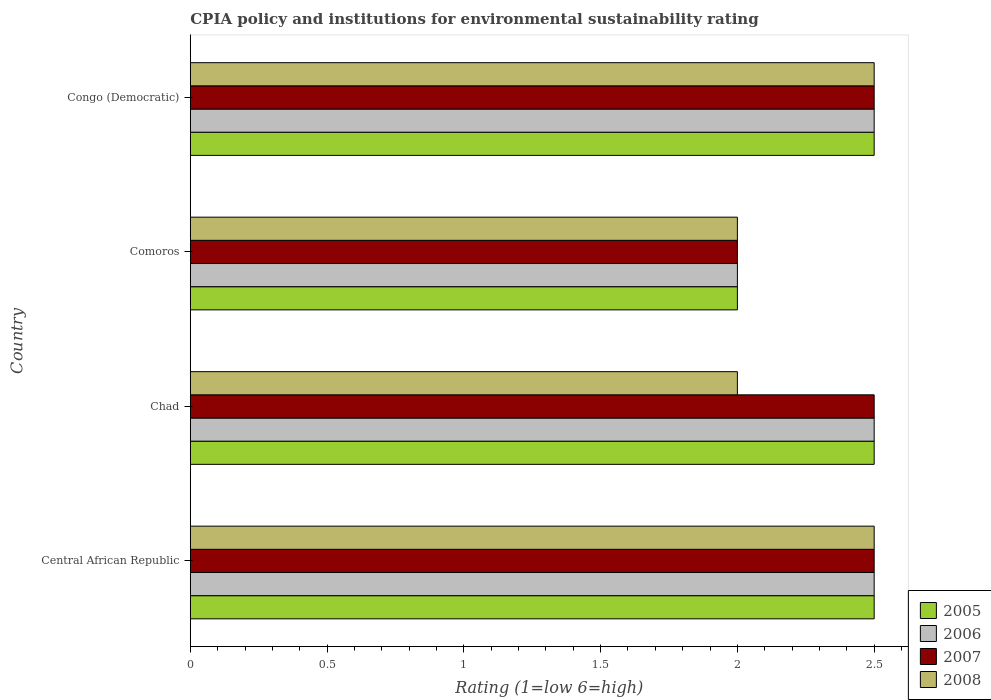How many groups of bars are there?
Make the answer very short. 4. Are the number of bars per tick equal to the number of legend labels?
Make the answer very short. Yes. Are the number of bars on each tick of the Y-axis equal?
Keep it short and to the point. Yes. How many bars are there on the 3rd tick from the top?
Offer a very short reply. 4. How many bars are there on the 1st tick from the bottom?
Your response must be concise. 4. What is the label of the 1st group of bars from the top?
Provide a short and direct response. Congo (Democratic). What is the CPIA rating in 2005 in Comoros?
Offer a terse response. 2. Across all countries, what is the minimum CPIA rating in 2007?
Your response must be concise. 2. In which country was the CPIA rating in 2007 maximum?
Your answer should be compact. Central African Republic. In which country was the CPIA rating in 2007 minimum?
Give a very brief answer. Comoros. What is the total CPIA rating in 2008 in the graph?
Offer a terse response. 9. What is the difference between the CPIA rating in 2007 in Congo (Democratic) and the CPIA rating in 2005 in Central African Republic?
Provide a succinct answer. 0. What is the average CPIA rating in 2007 per country?
Give a very brief answer. 2.38. What is the difference between the CPIA rating in 2007 and CPIA rating in 2006 in Congo (Democratic)?
Provide a succinct answer. 0. Is the difference between the CPIA rating in 2007 in Comoros and Congo (Democratic) greater than the difference between the CPIA rating in 2006 in Comoros and Congo (Democratic)?
Make the answer very short. No. What is the difference between the highest and the lowest CPIA rating in 2008?
Keep it short and to the point. 0.5. In how many countries, is the CPIA rating in 2007 greater than the average CPIA rating in 2007 taken over all countries?
Offer a very short reply. 3. How many countries are there in the graph?
Give a very brief answer. 4. What is the difference between two consecutive major ticks on the X-axis?
Give a very brief answer. 0.5. Are the values on the major ticks of X-axis written in scientific E-notation?
Offer a terse response. No. Does the graph contain grids?
Give a very brief answer. No. Where does the legend appear in the graph?
Your answer should be compact. Bottom right. What is the title of the graph?
Make the answer very short. CPIA policy and institutions for environmental sustainability rating. Does "1974" appear as one of the legend labels in the graph?
Keep it short and to the point. No. What is the Rating (1=low 6=high) in 2005 in Central African Republic?
Keep it short and to the point. 2.5. What is the Rating (1=low 6=high) of 2008 in Central African Republic?
Offer a terse response. 2.5. What is the Rating (1=low 6=high) in 2005 in Chad?
Your answer should be compact. 2.5. What is the Rating (1=low 6=high) of 2006 in Chad?
Offer a terse response. 2.5. What is the Rating (1=low 6=high) in 2007 in Comoros?
Make the answer very short. 2. What is the Rating (1=low 6=high) of 2008 in Comoros?
Ensure brevity in your answer.  2. What is the Rating (1=low 6=high) of 2006 in Congo (Democratic)?
Your answer should be compact. 2.5. Across all countries, what is the maximum Rating (1=low 6=high) of 2005?
Keep it short and to the point. 2.5. Across all countries, what is the maximum Rating (1=low 6=high) of 2007?
Offer a very short reply. 2.5. Across all countries, what is the maximum Rating (1=low 6=high) of 2008?
Your response must be concise. 2.5. Across all countries, what is the minimum Rating (1=low 6=high) of 2005?
Keep it short and to the point. 2. Across all countries, what is the minimum Rating (1=low 6=high) of 2006?
Your answer should be very brief. 2. Across all countries, what is the minimum Rating (1=low 6=high) of 2008?
Keep it short and to the point. 2. What is the total Rating (1=low 6=high) in 2005 in the graph?
Make the answer very short. 9.5. What is the total Rating (1=low 6=high) of 2008 in the graph?
Provide a short and direct response. 9. What is the difference between the Rating (1=low 6=high) of 2006 in Central African Republic and that in Chad?
Your answer should be very brief. 0. What is the difference between the Rating (1=low 6=high) in 2007 in Central African Republic and that in Chad?
Make the answer very short. 0. What is the difference between the Rating (1=low 6=high) in 2006 in Central African Republic and that in Congo (Democratic)?
Ensure brevity in your answer.  0. What is the difference between the Rating (1=low 6=high) in 2007 in Central African Republic and that in Congo (Democratic)?
Offer a very short reply. 0. What is the difference between the Rating (1=low 6=high) of 2008 in Central African Republic and that in Congo (Democratic)?
Provide a short and direct response. 0. What is the difference between the Rating (1=low 6=high) of 2006 in Chad and that in Comoros?
Your answer should be very brief. 0.5. What is the difference between the Rating (1=low 6=high) in 2008 in Chad and that in Comoros?
Give a very brief answer. 0. What is the difference between the Rating (1=low 6=high) of 2006 in Chad and that in Congo (Democratic)?
Keep it short and to the point. 0. What is the difference between the Rating (1=low 6=high) in 2007 in Chad and that in Congo (Democratic)?
Offer a very short reply. 0. What is the difference between the Rating (1=low 6=high) in 2008 in Chad and that in Congo (Democratic)?
Offer a very short reply. -0.5. What is the difference between the Rating (1=low 6=high) of 2006 in Comoros and that in Congo (Democratic)?
Make the answer very short. -0.5. What is the difference between the Rating (1=low 6=high) in 2008 in Comoros and that in Congo (Democratic)?
Your answer should be compact. -0.5. What is the difference between the Rating (1=low 6=high) in 2005 in Central African Republic and the Rating (1=low 6=high) in 2007 in Chad?
Give a very brief answer. 0. What is the difference between the Rating (1=low 6=high) of 2005 in Central African Republic and the Rating (1=low 6=high) of 2008 in Chad?
Give a very brief answer. 0.5. What is the difference between the Rating (1=low 6=high) in 2006 in Central African Republic and the Rating (1=low 6=high) in 2008 in Chad?
Ensure brevity in your answer.  0.5. What is the difference between the Rating (1=low 6=high) of 2007 in Central African Republic and the Rating (1=low 6=high) of 2008 in Chad?
Your answer should be very brief. 0.5. What is the difference between the Rating (1=low 6=high) of 2005 in Central African Republic and the Rating (1=low 6=high) of 2007 in Comoros?
Ensure brevity in your answer.  0.5. What is the difference between the Rating (1=low 6=high) in 2005 in Central African Republic and the Rating (1=low 6=high) in 2008 in Comoros?
Offer a terse response. 0.5. What is the difference between the Rating (1=low 6=high) of 2006 in Central African Republic and the Rating (1=low 6=high) of 2008 in Comoros?
Make the answer very short. 0.5. What is the difference between the Rating (1=low 6=high) of 2005 in Central African Republic and the Rating (1=low 6=high) of 2007 in Congo (Democratic)?
Your answer should be very brief. 0. What is the difference between the Rating (1=low 6=high) of 2005 in Central African Republic and the Rating (1=low 6=high) of 2008 in Congo (Democratic)?
Your answer should be very brief. 0. What is the difference between the Rating (1=low 6=high) of 2006 in Central African Republic and the Rating (1=low 6=high) of 2007 in Congo (Democratic)?
Your answer should be compact. 0. What is the difference between the Rating (1=low 6=high) in 2007 in Central African Republic and the Rating (1=low 6=high) in 2008 in Congo (Democratic)?
Make the answer very short. 0. What is the difference between the Rating (1=low 6=high) of 2005 in Chad and the Rating (1=low 6=high) of 2006 in Comoros?
Give a very brief answer. 0.5. What is the difference between the Rating (1=low 6=high) in 2005 in Chad and the Rating (1=low 6=high) in 2008 in Comoros?
Offer a terse response. 0.5. What is the difference between the Rating (1=low 6=high) in 2005 in Chad and the Rating (1=low 6=high) in 2008 in Congo (Democratic)?
Give a very brief answer. 0. What is the difference between the Rating (1=low 6=high) of 2005 in Comoros and the Rating (1=low 6=high) of 2006 in Congo (Democratic)?
Make the answer very short. -0.5. What is the difference between the Rating (1=low 6=high) in 2005 in Comoros and the Rating (1=low 6=high) in 2007 in Congo (Democratic)?
Provide a short and direct response. -0.5. What is the difference between the Rating (1=low 6=high) of 2005 in Comoros and the Rating (1=low 6=high) of 2008 in Congo (Democratic)?
Keep it short and to the point. -0.5. What is the difference between the Rating (1=low 6=high) in 2006 in Comoros and the Rating (1=low 6=high) in 2007 in Congo (Democratic)?
Make the answer very short. -0.5. What is the difference between the Rating (1=low 6=high) in 2006 in Comoros and the Rating (1=low 6=high) in 2008 in Congo (Democratic)?
Make the answer very short. -0.5. What is the difference between the Rating (1=low 6=high) in 2007 in Comoros and the Rating (1=low 6=high) in 2008 in Congo (Democratic)?
Ensure brevity in your answer.  -0.5. What is the average Rating (1=low 6=high) of 2005 per country?
Provide a succinct answer. 2.38. What is the average Rating (1=low 6=high) in 2006 per country?
Give a very brief answer. 2.38. What is the average Rating (1=low 6=high) of 2007 per country?
Your answer should be compact. 2.38. What is the average Rating (1=low 6=high) in 2008 per country?
Provide a short and direct response. 2.25. What is the difference between the Rating (1=low 6=high) in 2005 and Rating (1=low 6=high) in 2006 in Central African Republic?
Your answer should be very brief. 0. What is the difference between the Rating (1=low 6=high) in 2005 and Rating (1=low 6=high) in 2007 in Central African Republic?
Your answer should be very brief. 0. What is the difference between the Rating (1=low 6=high) in 2006 and Rating (1=low 6=high) in 2008 in Central African Republic?
Your response must be concise. 0. What is the difference between the Rating (1=low 6=high) of 2005 and Rating (1=low 6=high) of 2008 in Chad?
Provide a short and direct response. 0.5. What is the difference between the Rating (1=low 6=high) of 2006 and Rating (1=low 6=high) of 2008 in Chad?
Offer a terse response. 0.5. What is the difference between the Rating (1=low 6=high) in 2007 and Rating (1=low 6=high) in 2008 in Chad?
Ensure brevity in your answer.  0.5. What is the difference between the Rating (1=low 6=high) in 2007 and Rating (1=low 6=high) in 2008 in Comoros?
Offer a terse response. 0. What is the difference between the Rating (1=low 6=high) in 2005 and Rating (1=low 6=high) in 2007 in Congo (Democratic)?
Your answer should be very brief. 0. What is the difference between the Rating (1=low 6=high) in 2006 and Rating (1=low 6=high) in 2008 in Congo (Democratic)?
Offer a very short reply. 0. What is the difference between the Rating (1=low 6=high) of 2007 and Rating (1=low 6=high) of 2008 in Congo (Democratic)?
Ensure brevity in your answer.  0. What is the ratio of the Rating (1=low 6=high) of 2005 in Central African Republic to that in Chad?
Keep it short and to the point. 1. What is the ratio of the Rating (1=low 6=high) in 2006 in Central African Republic to that in Chad?
Give a very brief answer. 1. What is the ratio of the Rating (1=low 6=high) of 2006 in Central African Republic to that in Comoros?
Provide a short and direct response. 1.25. What is the ratio of the Rating (1=low 6=high) of 2007 in Central African Republic to that in Comoros?
Offer a very short reply. 1.25. What is the ratio of the Rating (1=low 6=high) in 2006 in Central African Republic to that in Congo (Democratic)?
Provide a short and direct response. 1. What is the ratio of the Rating (1=low 6=high) in 2007 in Central African Republic to that in Congo (Democratic)?
Provide a short and direct response. 1. What is the ratio of the Rating (1=low 6=high) in 2005 in Chad to that in Comoros?
Provide a succinct answer. 1.25. What is the ratio of the Rating (1=low 6=high) of 2006 in Chad to that in Comoros?
Provide a succinct answer. 1.25. What is the ratio of the Rating (1=low 6=high) of 2007 in Chad to that in Comoros?
Ensure brevity in your answer.  1.25. What is the ratio of the Rating (1=low 6=high) in 2008 in Chad to that in Comoros?
Provide a short and direct response. 1. What is the ratio of the Rating (1=low 6=high) in 2005 in Comoros to that in Congo (Democratic)?
Offer a very short reply. 0.8. What is the ratio of the Rating (1=low 6=high) in 2007 in Comoros to that in Congo (Democratic)?
Give a very brief answer. 0.8. What is the ratio of the Rating (1=low 6=high) in 2008 in Comoros to that in Congo (Democratic)?
Keep it short and to the point. 0.8. What is the difference between the highest and the second highest Rating (1=low 6=high) of 2006?
Provide a succinct answer. 0. What is the difference between the highest and the second highest Rating (1=low 6=high) in 2008?
Give a very brief answer. 0. What is the difference between the highest and the lowest Rating (1=low 6=high) in 2008?
Ensure brevity in your answer.  0.5. 